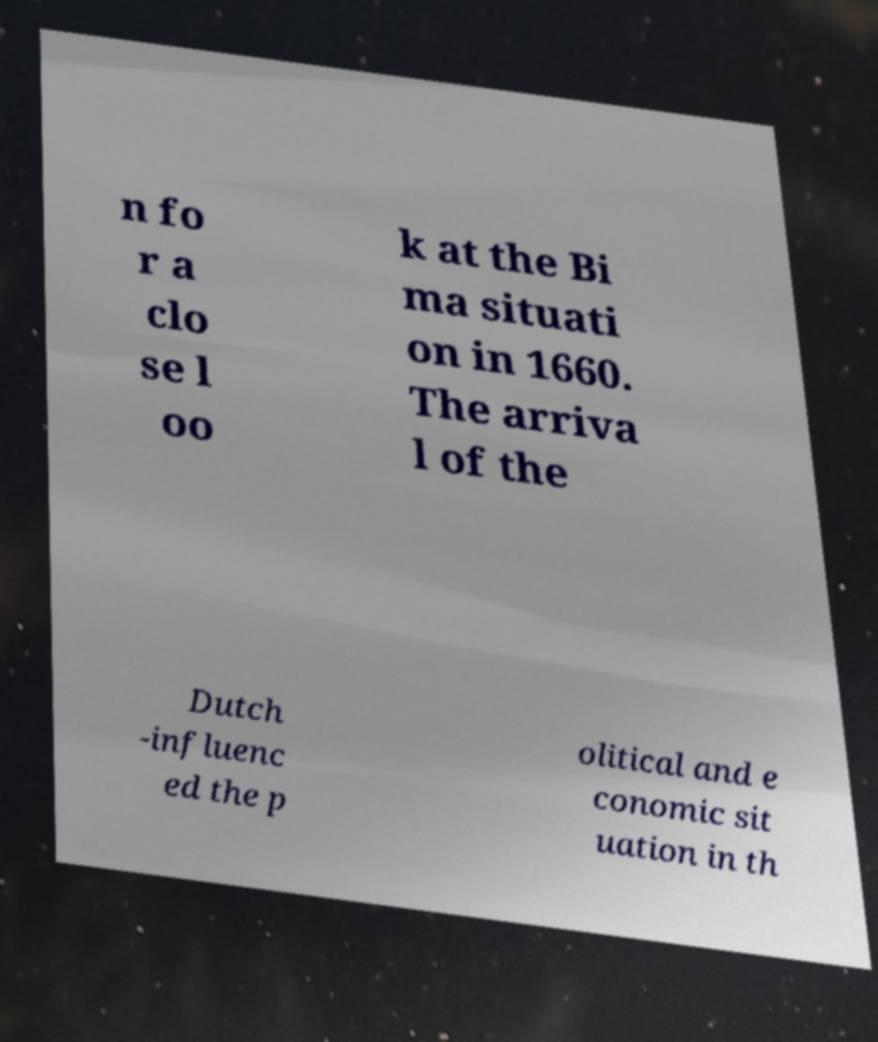Could you assist in decoding the text presented in this image and type it out clearly? n fo r a clo se l oo k at the Bi ma situati on in 1660. The arriva l of the Dutch -influenc ed the p olitical and e conomic sit uation in th 